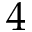<formula> <loc_0><loc_0><loc_500><loc_500>4</formula> 